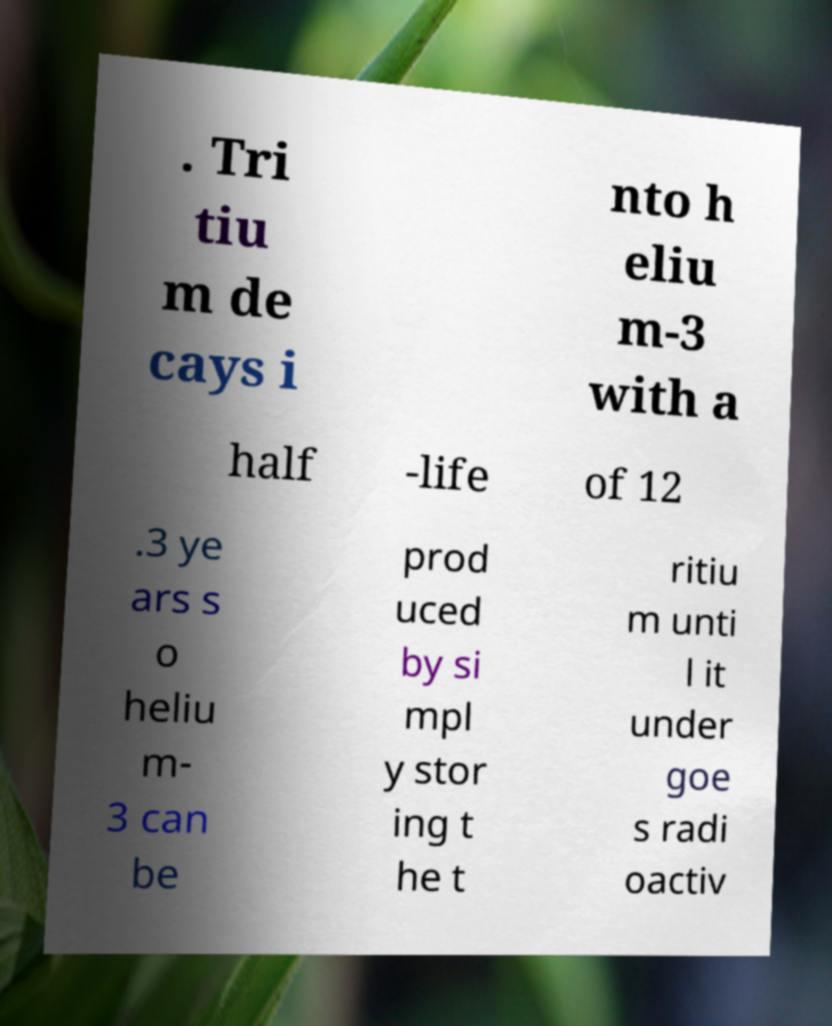Please identify and transcribe the text found in this image. . Tri tiu m de cays i nto h eliu m-3 with a half -life of 12 .3 ye ars s o heliu m- 3 can be prod uced by si mpl y stor ing t he t ritiu m unti l it under goe s radi oactiv 